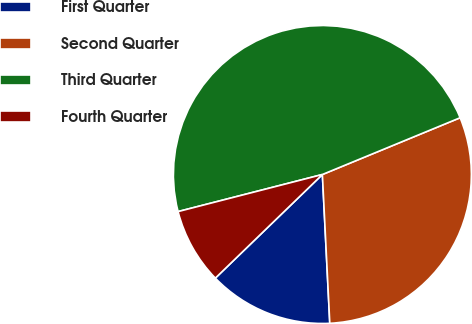Convert chart. <chart><loc_0><loc_0><loc_500><loc_500><pie_chart><fcel>First Quarter<fcel>Second Quarter<fcel>Third Quarter<fcel>Fourth Quarter<nl><fcel>13.55%<fcel>30.43%<fcel>47.78%<fcel>8.24%<nl></chart> 